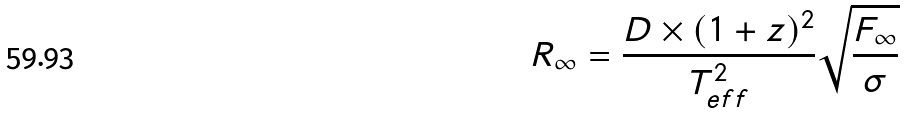<formula> <loc_0><loc_0><loc_500><loc_500>R _ { \infty } = \frac { D \times ( 1 + z ) ^ { 2 } } { T _ { e f f } ^ { 2 } } \sqrt { \frac { F _ { \infty } } { \sigma } }</formula> 